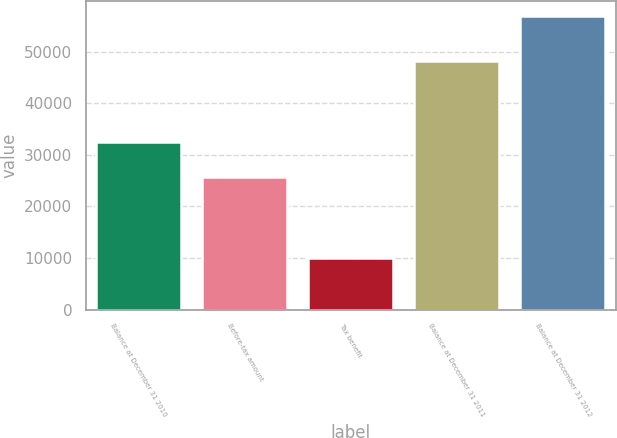Convert chart to OTSL. <chart><loc_0><loc_0><loc_500><loc_500><bar_chart><fcel>Balance at December 31 2010<fcel>Before-tax amount<fcel>Tax benefit<fcel>Balance at December 31 2011<fcel>Balance at December 31 2012<nl><fcel>32490<fcel>25622<fcel>10022<fcel>48090<fcel>56967<nl></chart> 